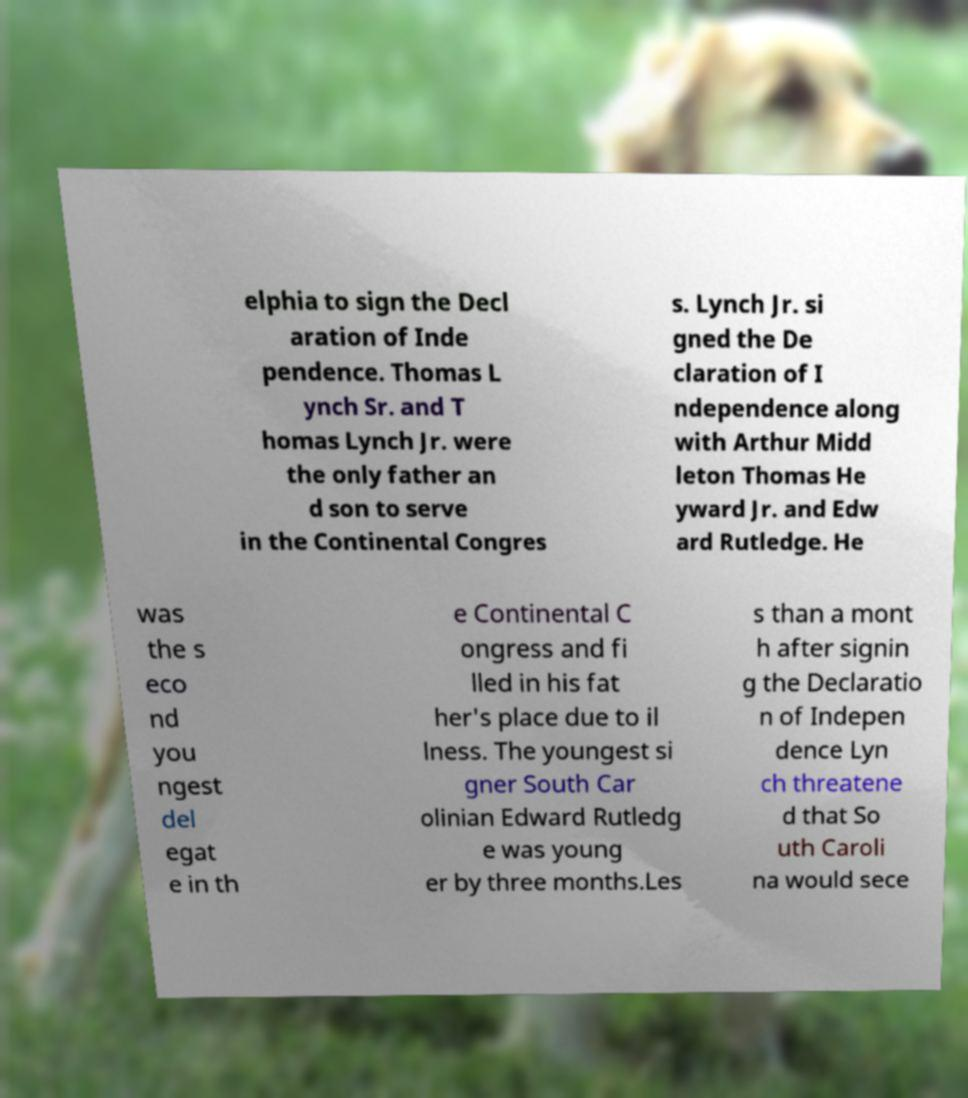Could you extract and type out the text from this image? elphia to sign the Decl aration of Inde pendence. Thomas L ynch Sr. and T homas Lynch Jr. were the only father an d son to serve in the Continental Congres s. Lynch Jr. si gned the De claration of I ndependence along with Arthur Midd leton Thomas He yward Jr. and Edw ard Rutledge. He was the s eco nd you ngest del egat e in th e Continental C ongress and fi lled in his fat her's place due to il lness. The youngest si gner South Car olinian Edward Rutledg e was young er by three months.Les s than a mont h after signin g the Declaratio n of Indepen dence Lyn ch threatene d that So uth Caroli na would sece 